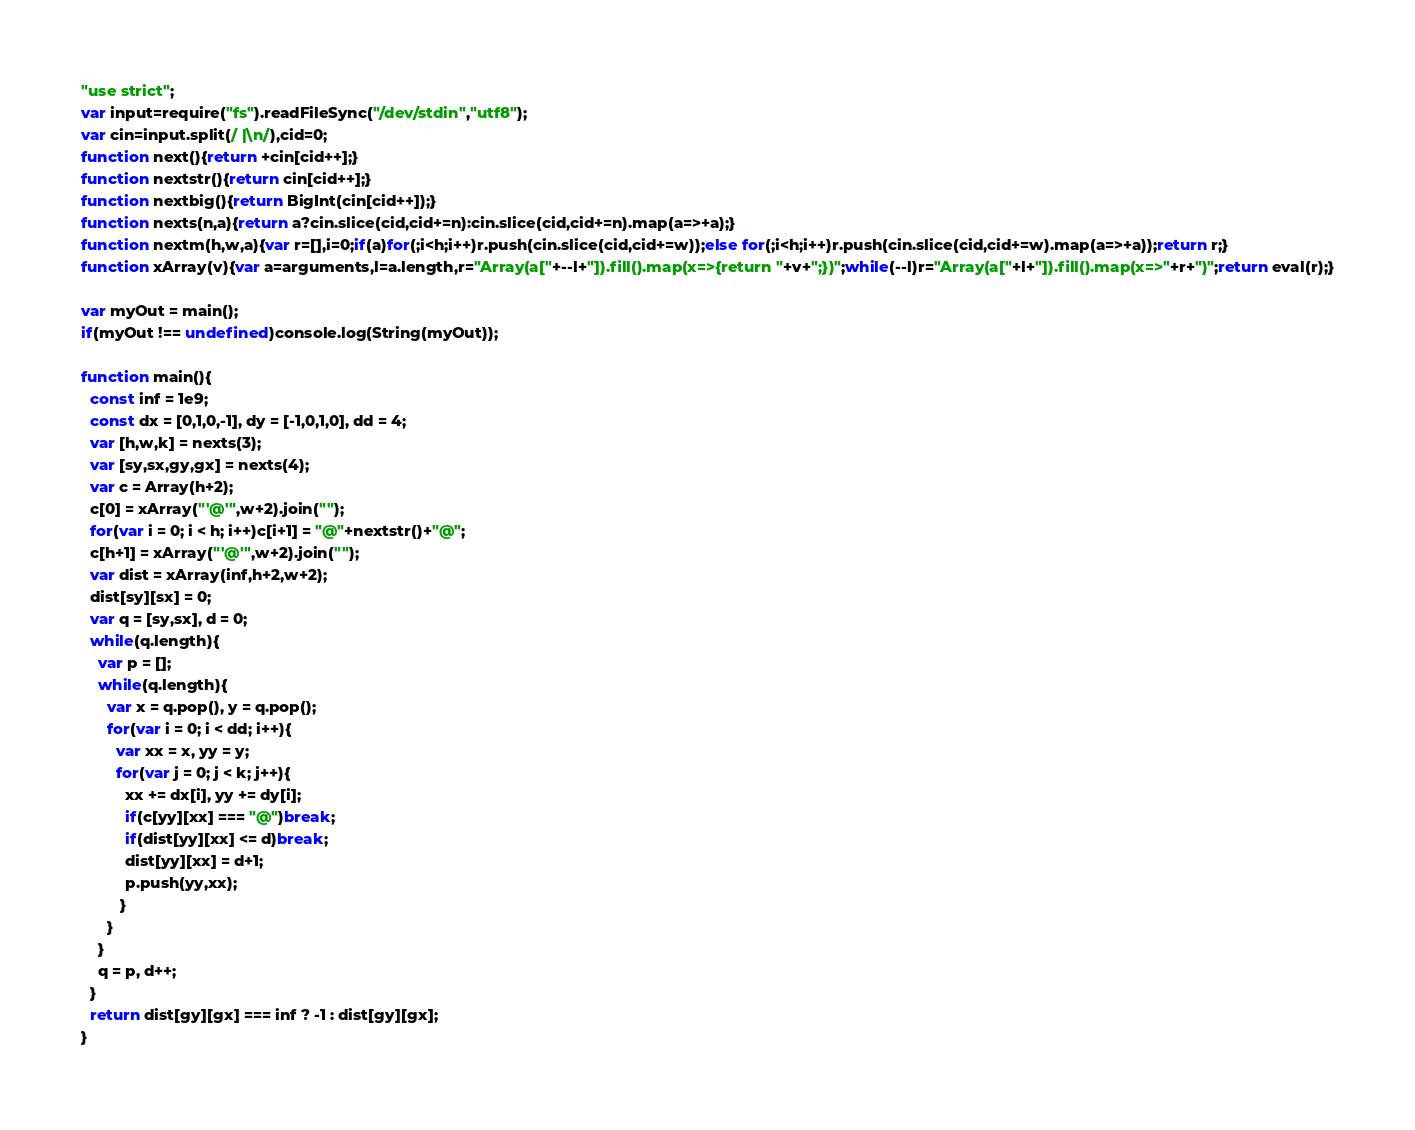<code> <loc_0><loc_0><loc_500><loc_500><_JavaScript_>"use strict";
var input=require("fs").readFileSync("/dev/stdin","utf8");
var cin=input.split(/ |\n/),cid=0;
function next(){return +cin[cid++];}
function nextstr(){return cin[cid++];}
function nextbig(){return BigInt(cin[cid++]);}
function nexts(n,a){return a?cin.slice(cid,cid+=n):cin.slice(cid,cid+=n).map(a=>+a);}
function nextm(h,w,a){var r=[],i=0;if(a)for(;i<h;i++)r.push(cin.slice(cid,cid+=w));else for(;i<h;i++)r.push(cin.slice(cid,cid+=w).map(a=>+a));return r;}
function xArray(v){var a=arguments,l=a.length,r="Array(a["+--l+"]).fill().map(x=>{return "+v+";})";while(--l)r="Array(a["+l+"]).fill().map(x=>"+r+")";return eval(r);}

var myOut = main();
if(myOut !== undefined)console.log(String(myOut));

function main(){
  const inf = 1e9;
  const dx = [0,1,0,-1], dy = [-1,0,1,0], dd = 4;
  var [h,w,k] = nexts(3);
  var [sy,sx,gy,gx] = nexts(4);
  var c = Array(h+2);
  c[0] = xArray("'@'",w+2).join("");
  for(var i = 0; i < h; i++)c[i+1] = "@"+nextstr()+"@";
  c[h+1] = xArray("'@'",w+2).join("");
  var dist = xArray(inf,h+2,w+2);
  dist[sy][sx] = 0;
  var q = [sy,sx], d = 0;
  while(q.length){
    var p = [];
    while(q.length){
      var x = q.pop(), y = q.pop();
      for(var i = 0; i < dd; i++){
        var xx = x, yy = y;
        for(var j = 0; j < k; j++){
          xx += dx[i], yy += dy[i];
          if(c[yy][xx] === "@")break;
          if(dist[yy][xx] <= d)break;
          dist[yy][xx] = d+1;
          p.push(yy,xx);
         }
      }
    }
    q = p, d++;
  }
  return dist[gy][gx] === inf ? -1 : dist[gy][gx];
}</code> 